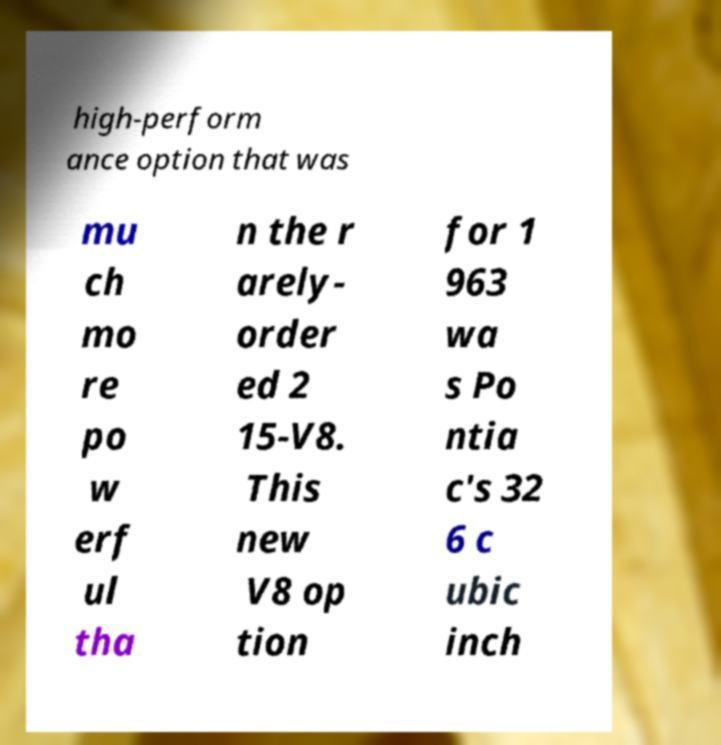What messages or text are displayed in this image? I need them in a readable, typed format. high-perform ance option that was mu ch mo re po w erf ul tha n the r arely- order ed 2 15-V8. This new V8 op tion for 1 963 wa s Po ntia c's 32 6 c ubic inch 